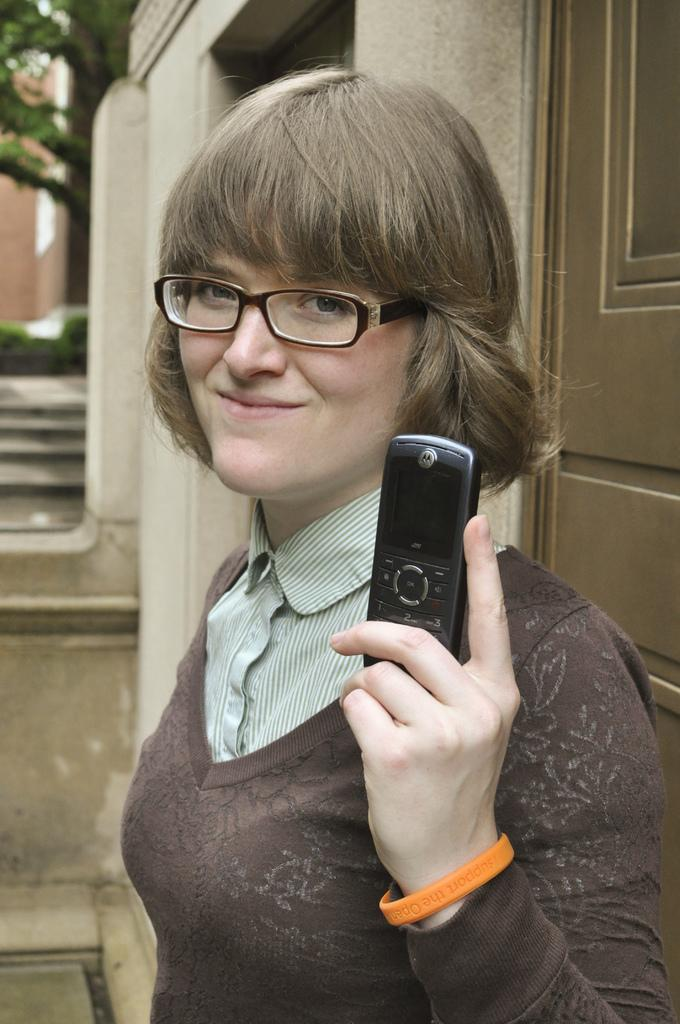What is the woman doing in the image? She is standing in the image. What is she holding in her hand? She is holding a mobile in her hand. Is there any accessory she is wearing? Yes, she is wearing a spectacle. What is her facial expression? She is smiling in the image. What can be seen in the background of the image? There are trees and a door visible in the background. How many dimes can be found in her pocket in the image? There is no mention of a pocket or dimes in the image, so we cannot determine the number of dimes in her pocket. 